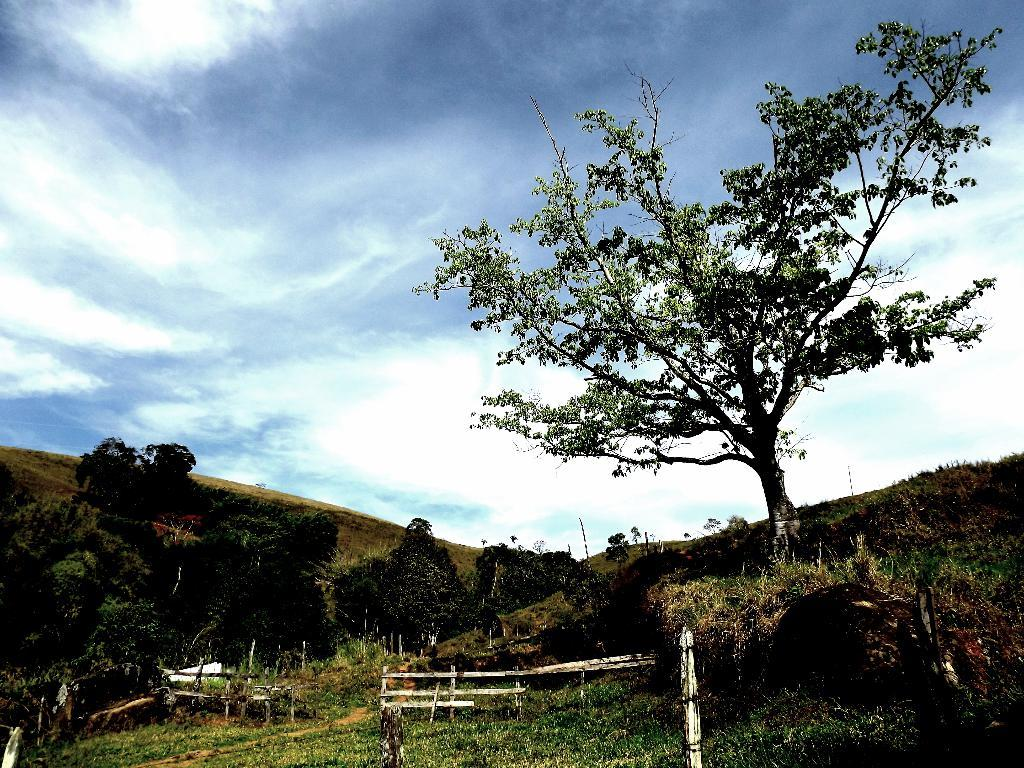What type of vegetation can be seen in the image? There are trees in the image. What objects are on the ground in the image? There are wooden objects on the ground in the image. What is visible in the background of the image? The sky is visible in the background of the image. What can be seen in the sky in the image? Clouds are present in the sky. What type of hat is the tree wearing in the image? There are no hats present in the image, as trees do not wear apparel. 